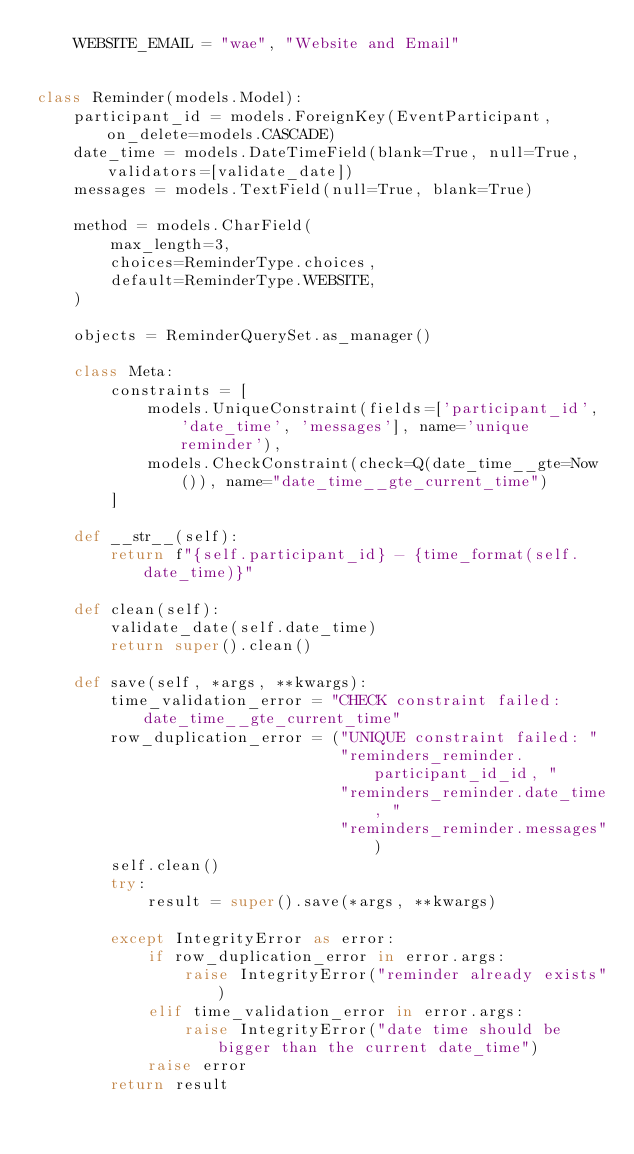Convert code to text. <code><loc_0><loc_0><loc_500><loc_500><_Python_>    WEBSITE_EMAIL = "wae", "Website and Email"


class Reminder(models.Model):
    participant_id = models.ForeignKey(EventParticipant, on_delete=models.CASCADE)
    date_time = models.DateTimeField(blank=True, null=True, validators=[validate_date])
    messages = models.TextField(null=True, blank=True)

    method = models.CharField(
        max_length=3,
        choices=ReminderType.choices,
        default=ReminderType.WEBSITE,
    )

    objects = ReminderQuerySet.as_manager()

    class Meta:
        constraints = [
            models.UniqueConstraint(fields=['participant_id', 'date_time', 'messages'], name='unique reminder'),
            models.CheckConstraint(check=Q(date_time__gte=Now()), name="date_time__gte_current_time")
        ]

    def __str__(self):
        return f"{self.participant_id} - {time_format(self.date_time)}"

    def clean(self):
        validate_date(self.date_time)
        return super().clean()

    def save(self, *args, **kwargs):
        time_validation_error = "CHECK constraint failed: date_time__gte_current_time"
        row_duplication_error = ("UNIQUE constraint failed: "
                                 "reminders_reminder.participant_id_id, "
                                 "reminders_reminder.date_time, "
                                 "reminders_reminder.messages")
        self.clean()
        try:
            result = super().save(*args, **kwargs)

        except IntegrityError as error:
            if row_duplication_error in error.args:
                raise IntegrityError("reminder already exists")
            elif time_validation_error in error.args:
                raise IntegrityError("date time should be bigger than the current date_time")
            raise error
        return result
</code> 